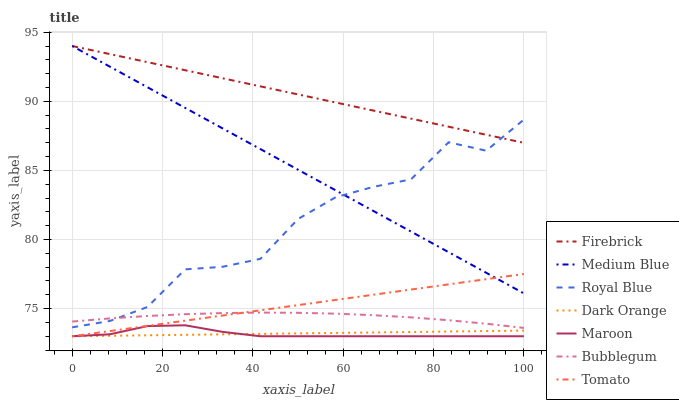Does Maroon have the minimum area under the curve?
Answer yes or no. Yes. Does Firebrick have the maximum area under the curve?
Answer yes or no. Yes. Does Dark Orange have the minimum area under the curve?
Answer yes or no. No. Does Dark Orange have the maximum area under the curve?
Answer yes or no. No. Is Dark Orange the smoothest?
Answer yes or no. Yes. Is Royal Blue the roughest?
Answer yes or no. Yes. Is Firebrick the smoothest?
Answer yes or no. No. Is Firebrick the roughest?
Answer yes or no. No. Does Tomato have the lowest value?
Answer yes or no. Yes. Does Firebrick have the lowest value?
Answer yes or no. No. Does Medium Blue have the highest value?
Answer yes or no. Yes. Does Dark Orange have the highest value?
Answer yes or no. No. Is Dark Orange less than Medium Blue?
Answer yes or no. Yes. Is Bubblegum greater than Maroon?
Answer yes or no. Yes. Does Bubblegum intersect Tomato?
Answer yes or no. Yes. Is Bubblegum less than Tomato?
Answer yes or no. No. Is Bubblegum greater than Tomato?
Answer yes or no. No. Does Dark Orange intersect Medium Blue?
Answer yes or no. No. 